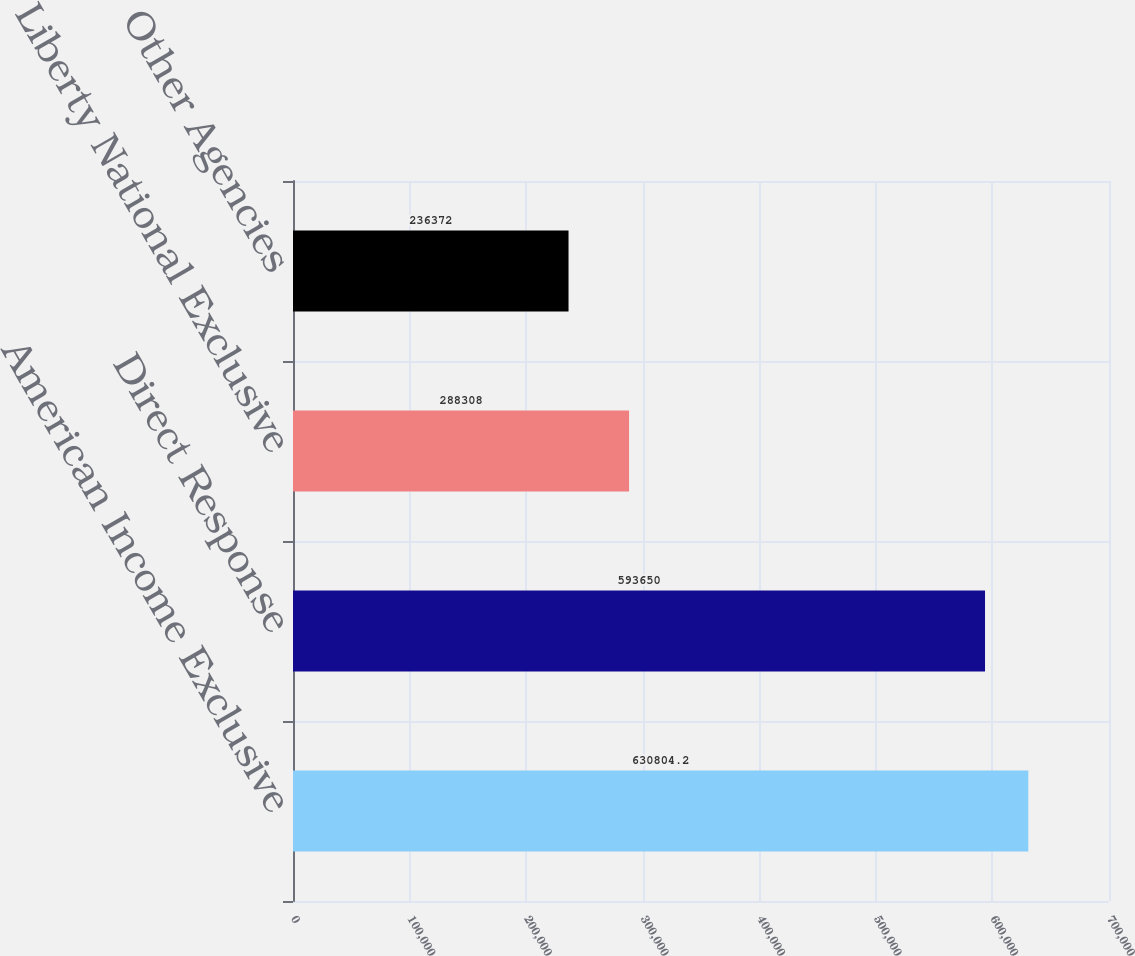Convert chart to OTSL. <chart><loc_0><loc_0><loc_500><loc_500><bar_chart><fcel>American Income Exclusive<fcel>Direct Response<fcel>Liberty National Exclusive<fcel>Other Agencies<nl><fcel>630804<fcel>593650<fcel>288308<fcel>236372<nl></chart> 